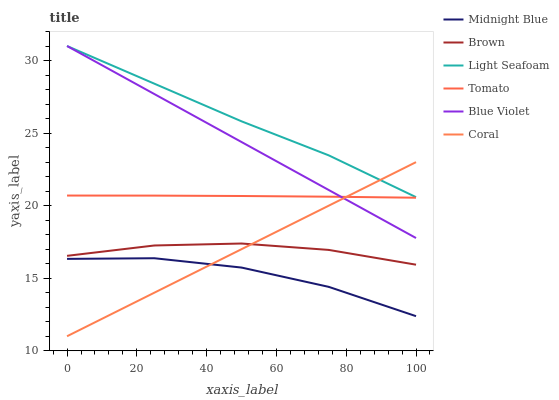Does Midnight Blue have the minimum area under the curve?
Answer yes or no. Yes. Does Light Seafoam have the maximum area under the curve?
Answer yes or no. Yes. Does Brown have the minimum area under the curve?
Answer yes or no. No. Does Brown have the maximum area under the curve?
Answer yes or no. No. Is Blue Violet the smoothest?
Answer yes or no. Yes. Is Midnight Blue the roughest?
Answer yes or no. Yes. Is Brown the smoothest?
Answer yes or no. No. Is Brown the roughest?
Answer yes or no. No. Does Brown have the lowest value?
Answer yes or no. No. Does Blue Violet have the highest value?
Answer yes or no. Yes. Does Brown have the highest value?
Answer yes or no. No. Is Brown less than Tomato?
Answer yes or no. Yes. Is Light Seafoam greater than Midnight Blue?
Answer yes or no. Yes. Does Coral intersect Midnight Blue?
Answer yes or no. Yes. Is Coral less than Midnight Blue?
Answer yes or no. No. Is Coral greater than Midnight Blue?
Answer yes or no. No. Does Brown intersect Tomato?
Answer yes or no. No. 